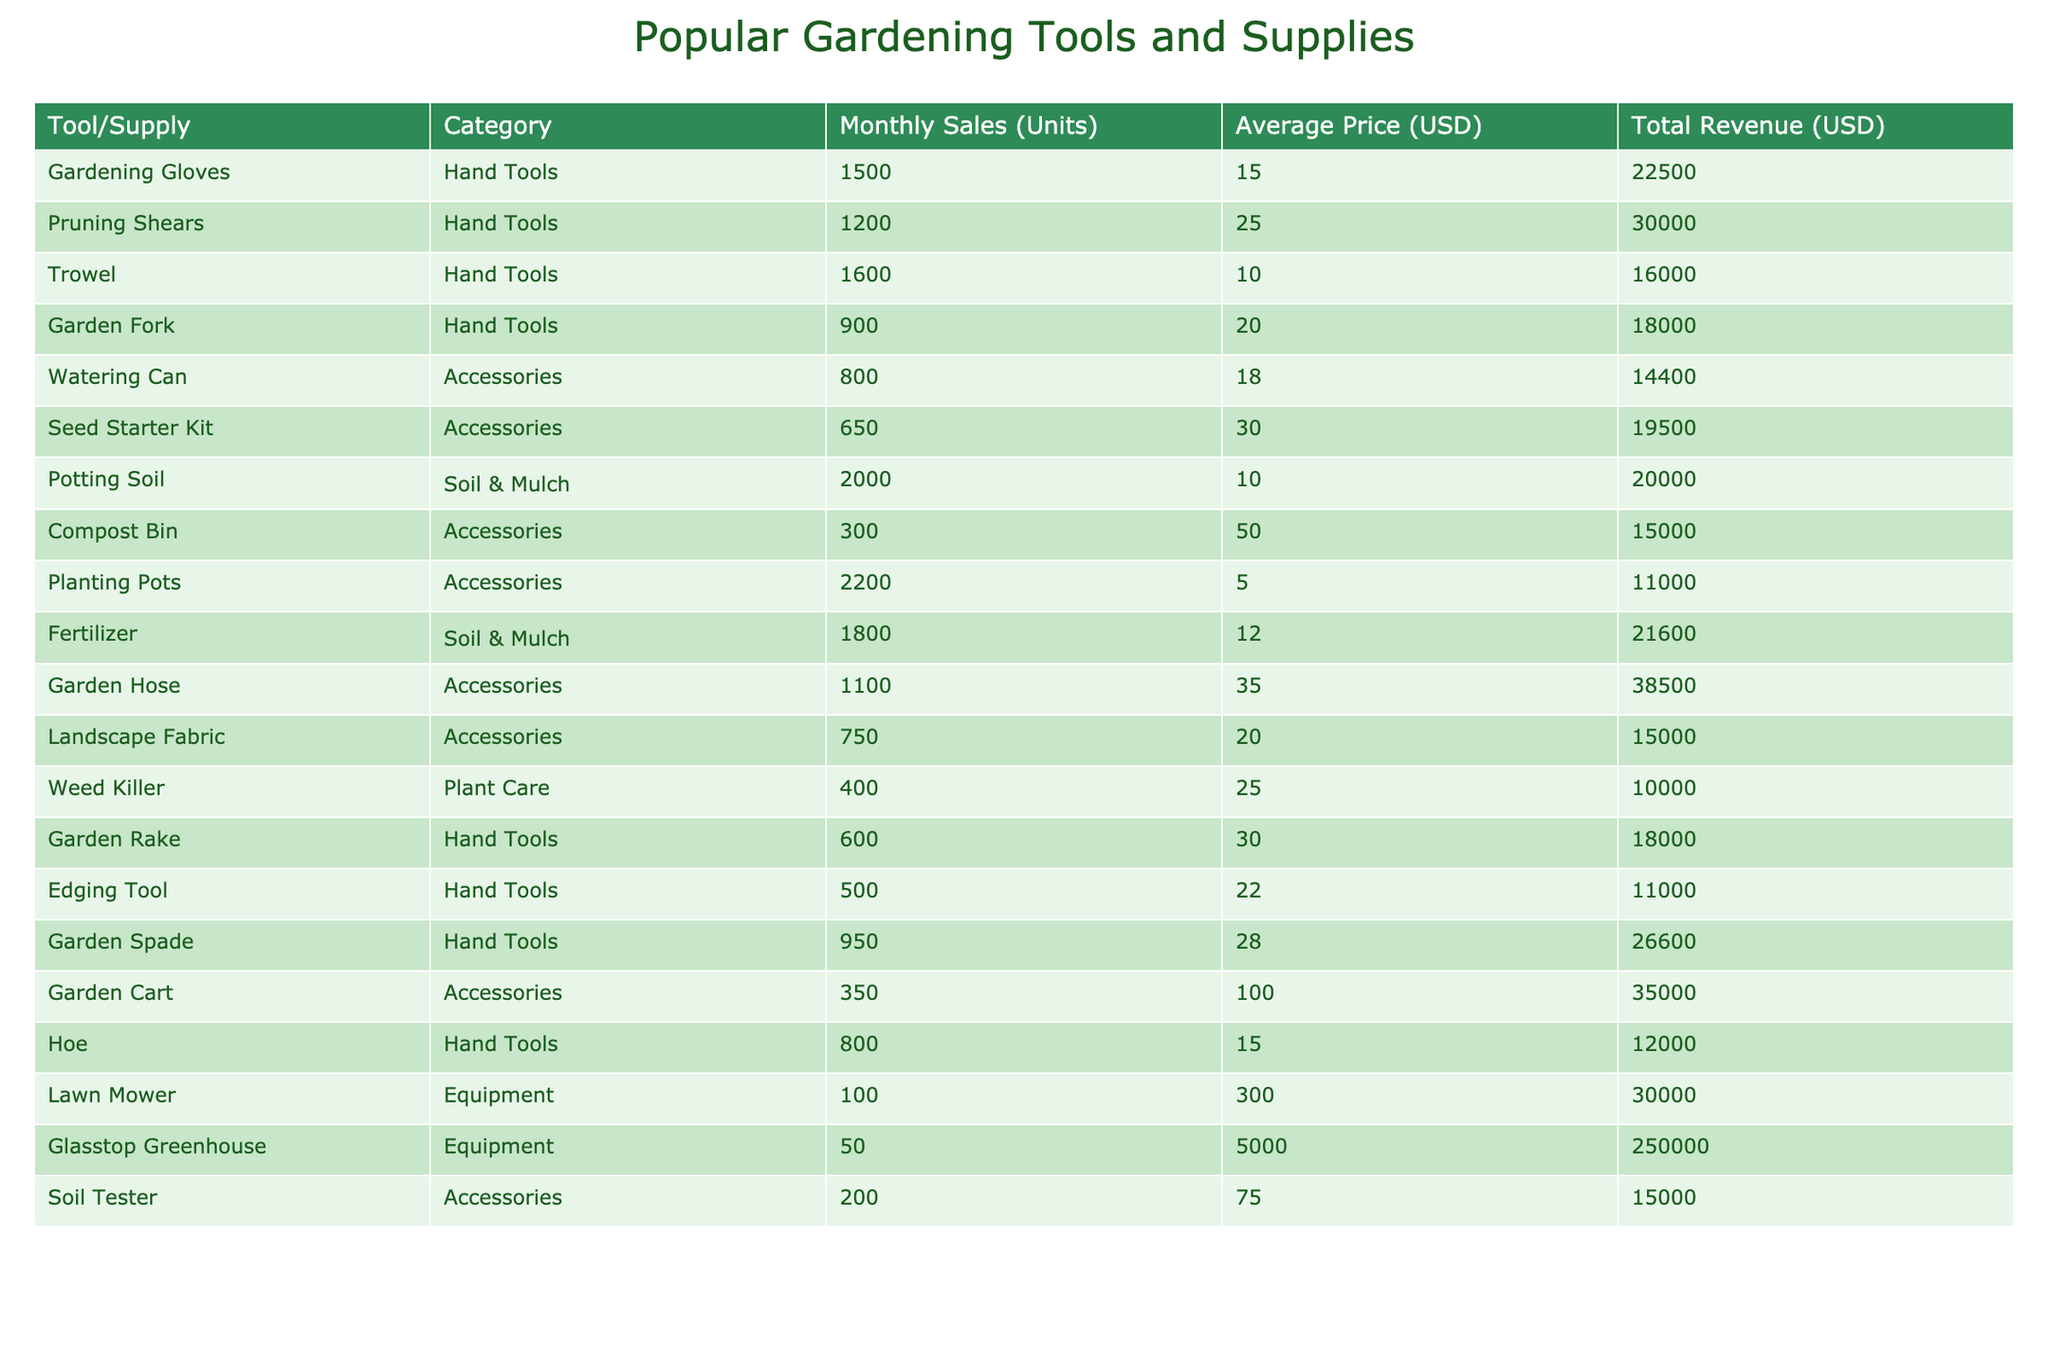What is the total revenue generated by the Garden Fork? The revenue for the Garden Fork can be found in the Total Revenue column of the table, where the value for the Garden Fork is 18000 USD.
Answer: 18000 USD How many units were sold of the Planting Pots? The number of units sold for the Planting Pots is directly given in the Monthly Sales (Units) column, which shows 2200 units.
Answer: 2200 units Which tool has the highest average price? To find the tool with the highest average price, we can look at the Average Price (USD) column and find that the Glasstop Greenhouse has the highest price at 5000 USD.
Answer: Glasstop Greenhouse What is the difference in monthly sales between the Pruning Shears and the Hoe? The Pruning Shears sold 1200 units, while the Hoe sold 800 units. The difference is calculated as 1200 - 800 = 400 units.
Answer: 400 units Is the total revenue for the Fertilizer greater than that for the Compost Bin? The total revenue for the Fertilizer is 21600 USD, and for the Compost Bin, it is 15000 USD. Since 21600 is greater than 15000, the statement is true.
Answer: Yes What is the average number of units sold for all Hand Tools? The Hand Tools and their monthly sales are: Gardening Gloves (1500), Pruning Shears (1200), Trowel (1600), Garden Fork (900), Garden Rake (600), Edging Tool (500), Garden Spade (950), and Hoe (800). First, we sum these values: 1500 + 1200 + 1600 + 900 + 600 + 500 + 950 + 800 = 6300. Since there are 8 Hand Tool items, we divide by 8: 6300 / 8 = 787.5 units.
Answer: 787.5 units How many total units were sold across all Accessories? The monthly sales for Accessories are: Watering Can (800), Seed Starter Kit (650), Compost Bin (300), Planting Pots (2200), Garden Hose (1100), Landscape Fabric (750), and Garden Cart (350). Sum these sales: 800 + 650 + 300 + 2200 + 1100 + 750 + 350 = 5150 units.
Answer: 5150 units Does the Trowel have a higher total revenue than the Garden Rake? The total revenues are 16000 USD for the Trowel and 18000 USD for the Garden Rake. Since 16000 is less than 18000, the statement is false.
Answer: No What percentage of total revenue does the Lawn Mower contribute? The total revenue of the Lawn Mower is 30000 USD. To find the total revenue of all items, we sum the Total Revenues which equals 380300 USD. The percentage contributed is (30000 / 380300) * 100 = 7.88%.
Answer: 7.88% 